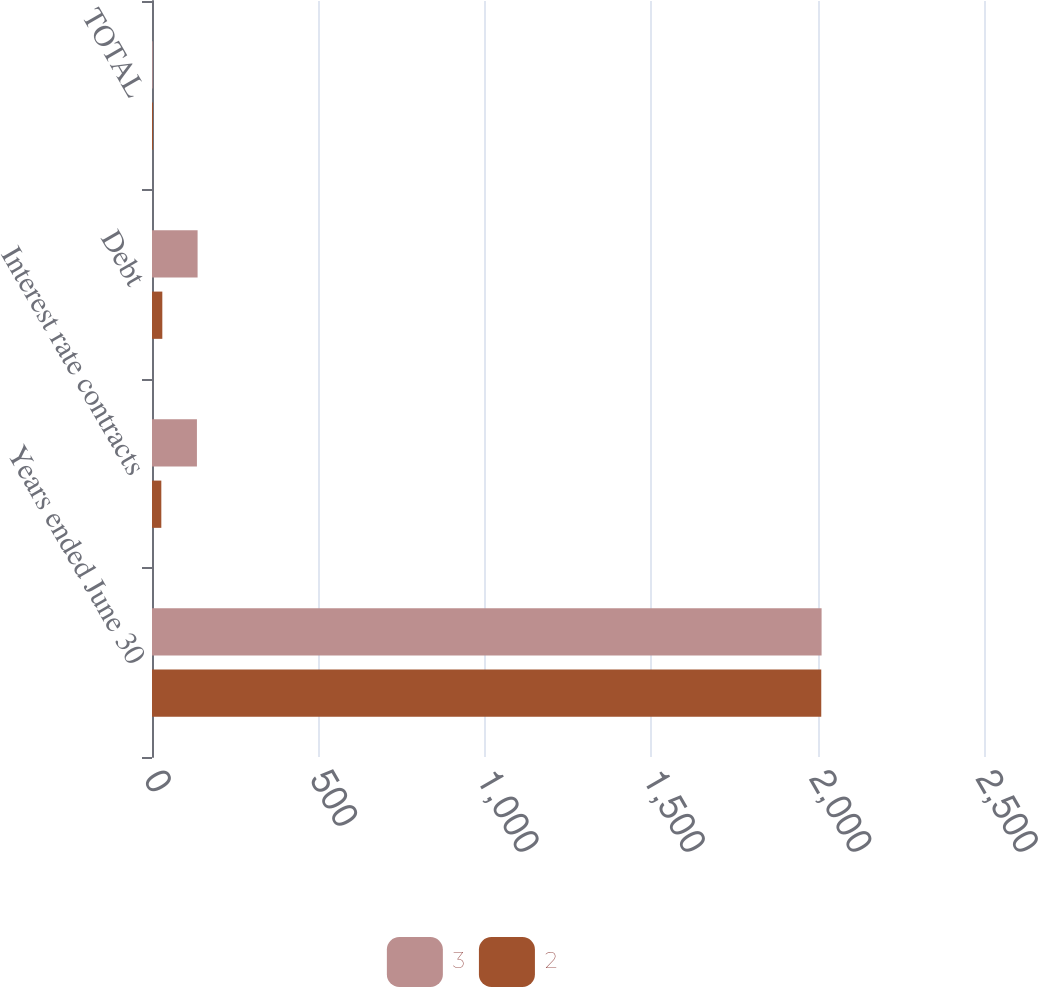<chart> <loc_0><loc_0><loc_500><loc_500><stacked_bar_chart><ecel><fcel>Years ended June 30<fcel>Interest rate contracts<fcel>Debt<fcel>TOTAL<nl><fcel>3<fcel>2012<fcel>135<fcel>137<fcel>2<nl><fcel>2<fcel>2011<fcel>28<fcel>31<fcel>3<nl></chart> 